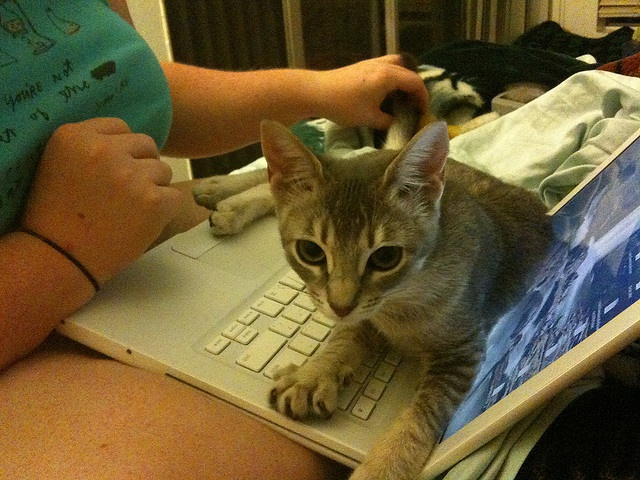Describe the objects in this image and their specific colors. I can see laptop in black, tan, olive, and gray tones, people in black, maroon, brown, and darkgreen tones, and cat in black and olive tones in this image. 